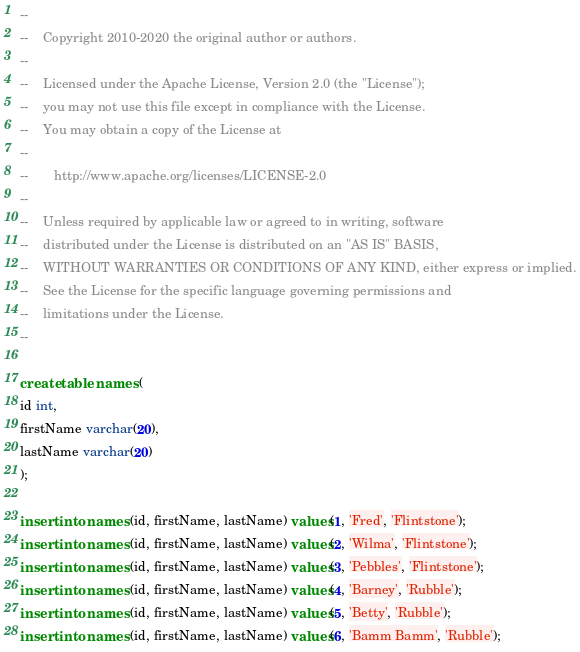<code> <loc_0><loc_0><loc_500><loc_500><_SQL_>--
--    Copyright 2010-2020 the original author or authors.
--
--    Licensed under the Apache License, Version 2.0 (the "License");
--    you may not use this file except in compliance with the License.
--    You may obtain a copy of the License at
--
--       http://www.apache.org/licenses/LICENSE-2.0
--
--    Unless required by applicable law or agreed to in writing, software
--    distributed under the License is distributed on an "AS IS" BASIS,
--    WITHOUT WARRANTIES OR CONDITIONS OF ANY KIND, either express or implied.
--    See the License for the specific language governing permissions and
--    limitations under the License.
--

create table names (
id int,
firstName varchar(20),
lastName varchar(20)
);

insert into names (id, firstName, lastName) values(1, 'Fred', 'Flintstone');
insert into names (id, firstName, lastName) values(2, 'Wilma', 'Flintstone');
insert into names (id, firstName, lastName) values(3, 'Pebbles', 'Flintstone');
insert into names (id, firstName, lastName) values(4, 'Barney', 'Rubble');
insert into names (id, firstName, lastName) values(5, 'Betty', 'Rubble');
insert into names (id, firstName, lastName) values(6, 'Bamm Bamm', 'Rubble');
</code> 